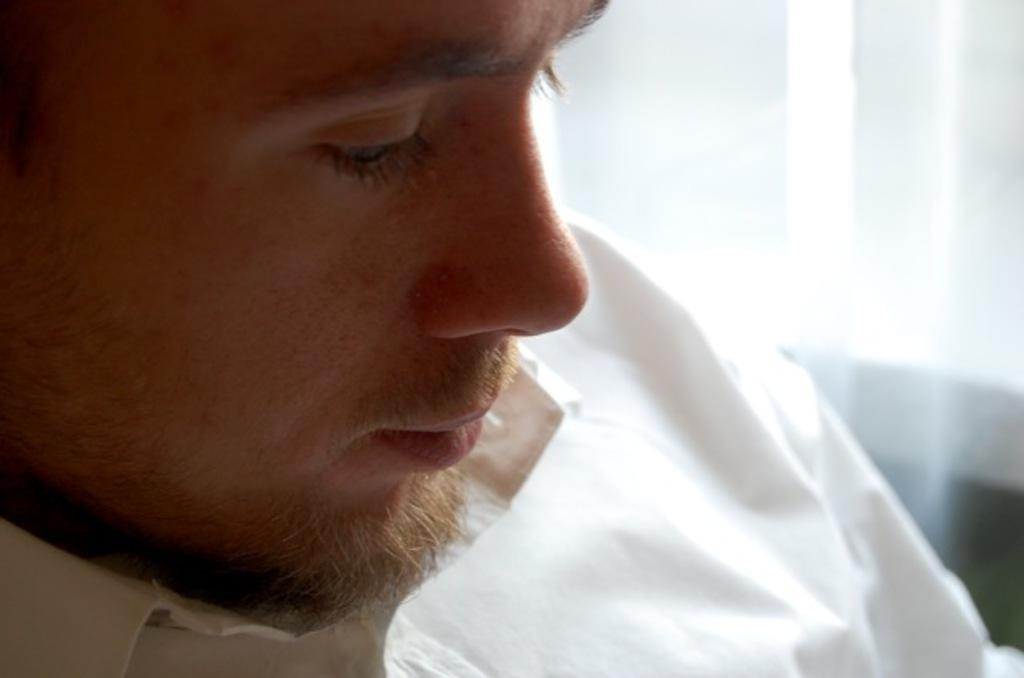Who is present in the image? There is a man in the image. What is the man wearing in the image? The man is wearing a white shirt in the image. What can be seen in the background of the image? The background of the image is white. What type of meat is the man holding in the image? There is no meat present in the image; the man is not holding anything. 